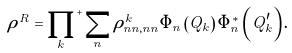Convert formula to latex. <formula><loc_0><loc_0><loc_500><loc_500>\rho ^ { R } = { \prod _ { k } } ^ { + } \sum _ { n } \rho ^ { k } _ { n n , n n } \Phi _ { n } \left ( Q _ { k } \right ) \Phi ^ { * } _ { n } \left ( Q ^ { \prime } _ { k } \right ) .</formula> 